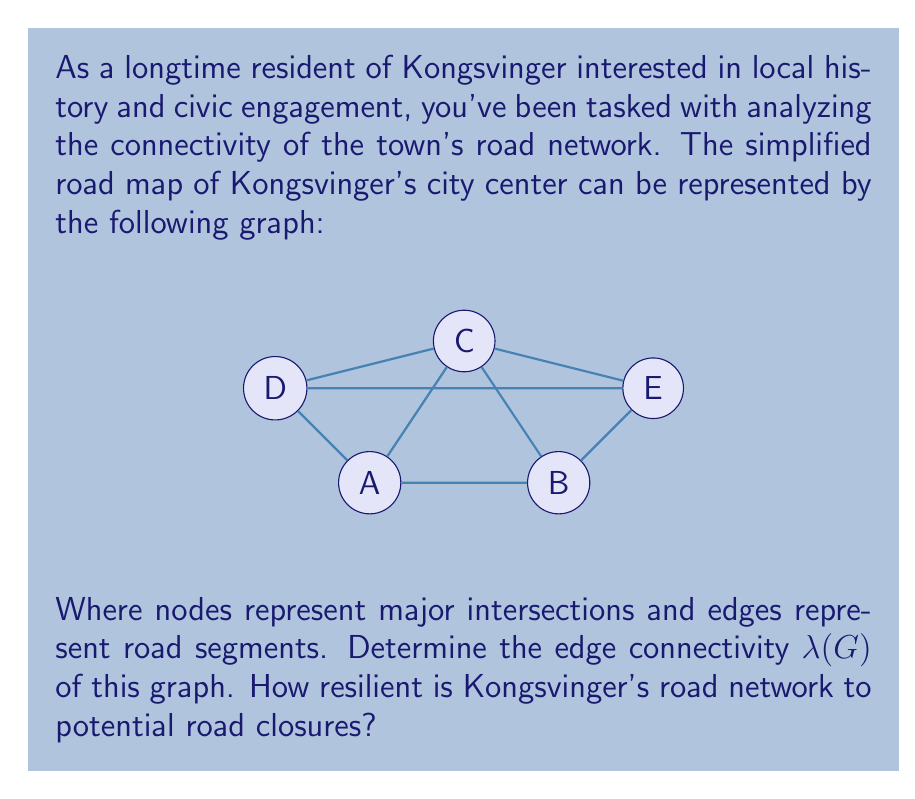Can you solve this math problem? To determine the edge connectivity $\lambda(G)$ of the graph representing Kongsvinger's road network, we need to follow these steps:

1) First, recall that the edge connectivity $\lambda(G)$ is defined as the minimum number of edges that need to be removed to disconnect the graph.

2) In this graph, we have 5 vertices (A, B, C, D, E) and 8 edges.

3) To find $\lambda(G)$, we need to identify the minimum cut set - the smallest set of edges whose removal would disconnect the graph.

4) Let's examine the possible cuts:
   - Removing edges AC and BC disconnects C from the rest of the graph.
   - Removing edges AD and CD disconnects D from the rest of the graph.
   - Removing edges BE and CE disconnects E from the rest of the graph.

5) In each case, we need to remove 2 edges to disconnect a vertex from the rest of the graph.

6) There is no way to disconnect the graph by removing only one edge.

7) Therefore, the edge connectivity $\lambda(G) = 2$.

8) Interpreting this result in the context of Kongsvinger's road network:
   - The network is 2-edge-connected, meaning it can withstand the closure of any single road without becoming disconnected.
   - However, there are critical pairs of roads whose simultaneous closure would isolate parts of the town.

This analysis suggests that while Kongsvinger's road network has some resilience to closures, there are potential vulnerabilities that civic planners might want to address to improve connectivity.
Answer: $\lambda(G) = 2$ 